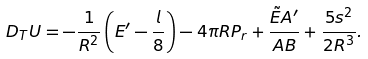<formula> <loc_0><loc_0><loc_500><loc_500>D _ { T } U = - \frac { 1 } { R ^ { 2 } } \left ( E ^ { \prime } - \frac { l } { 8 } \right ) - 4 \pi { R } P _ { r } + \frac { \tilde { E } A ^ { \prime } } { A B } + \frac { 5 s ^ { 2 } } { 2 R ^ { 3 } } .</formula> 